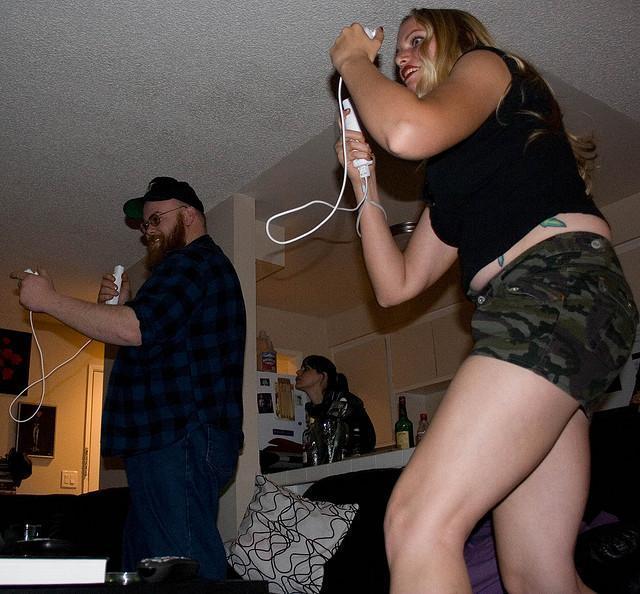What video game console is being played by the two people in front?
Make your selection from the four choices given to correctly answer the question.
Options: Ps5, nintendo wii, steambox, xbox. Nintendo wii. 